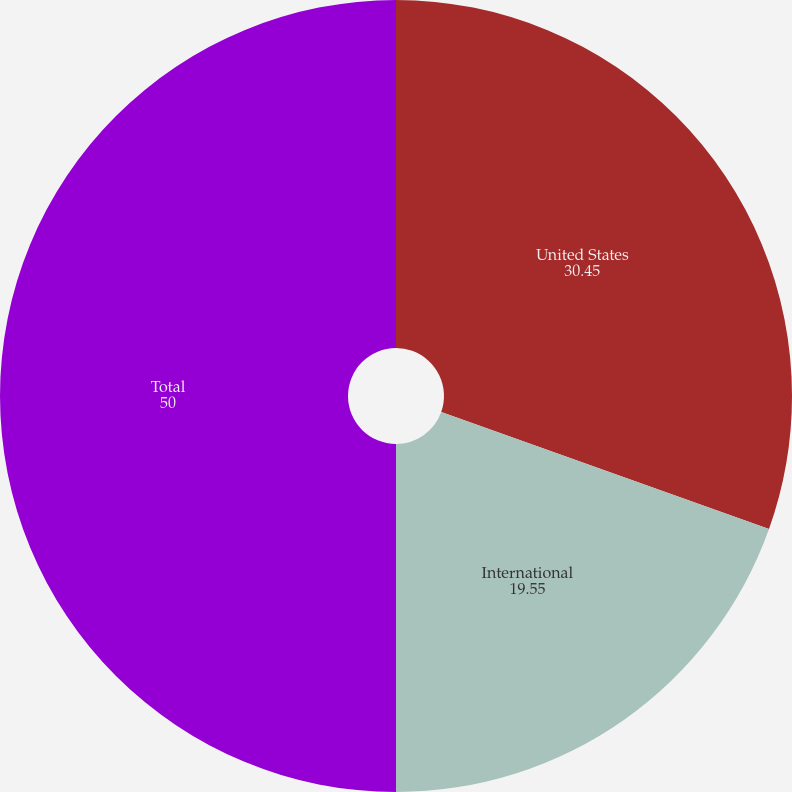Convert chart. <chart><loc_0><loc_0><loc_500><loc_500><pie_chart><fcel>United States<fcel>International<fcel>Total<nl><fcel>30.45%<fcel>19.55%<fcel>50.0%<nl></chart> 